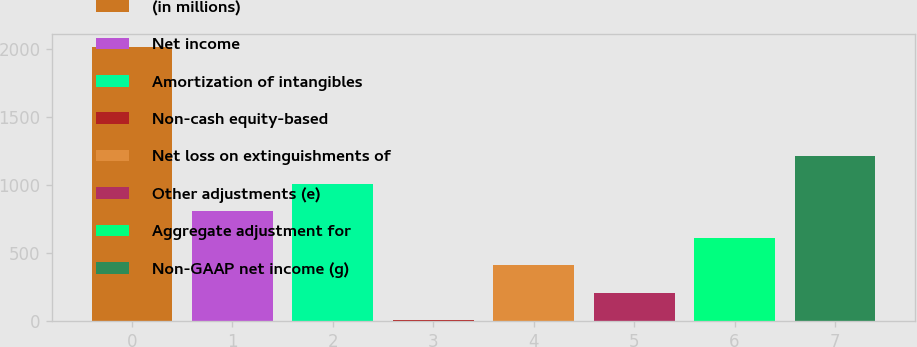Convert chart to OTSL. <chart><loc_0><loc_0><loc_500><loc_500><bar_chart><fcel>(in millions)<fcel>Net income<fcel>Amortization of intangibles<fcel>Non-cash equity-based<fcel>Net loss on extinguishments of<fcel>Other adjustments (e)<fcel>Aggregate adjustment for<fcel>Non-GAAP net income (g)<nl><fcel>2013<fcel>810.36<fcel>1010.8<fcel>8.6<fcel>409.48<fcel>209.04<fcel>609.92<fcel>1211.24<nl></chart> 